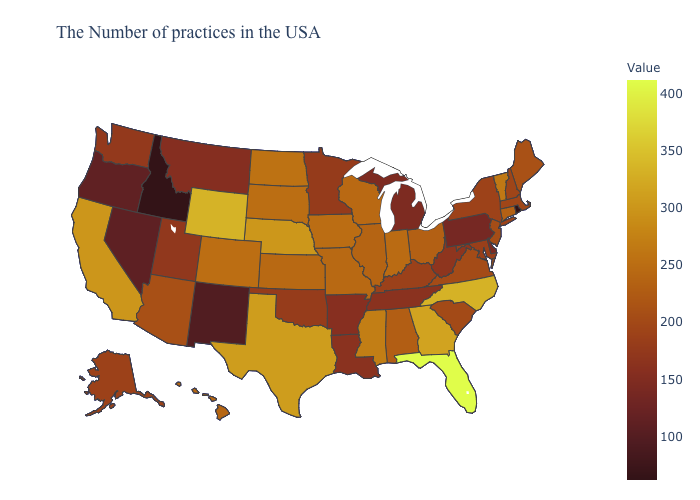Does the map have missing data?
Short answer required. No. Does Wisconsin have the highest value in the MidWest?
Give a very brief answer. No. Which states hav the highest value in the South?
Give a very brief answer. Florida. Does Delaware have the lowest value in the USA?
Give a very brief answer. No. Does Idaho have the lowest value in the USA?
Be succinct. Yes. Which states have the lowest value in the South?
Quick response, please. Delaware. Which states hav the highest value in the South?
Answer briefly. Florida. Which states have the lowest value in the Northeast?
Concise answer only. Rhode Island. 